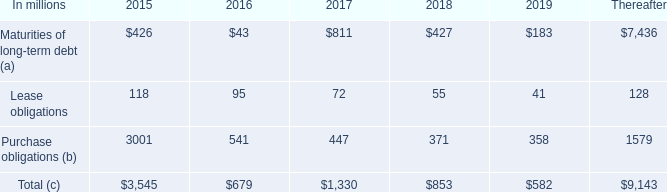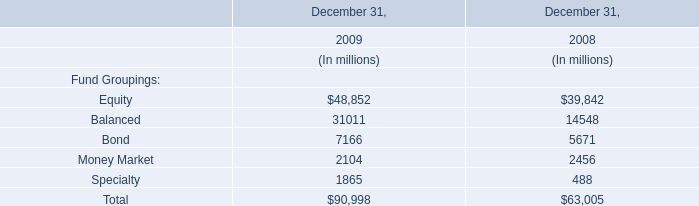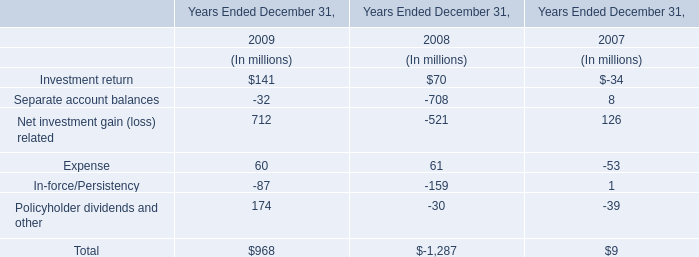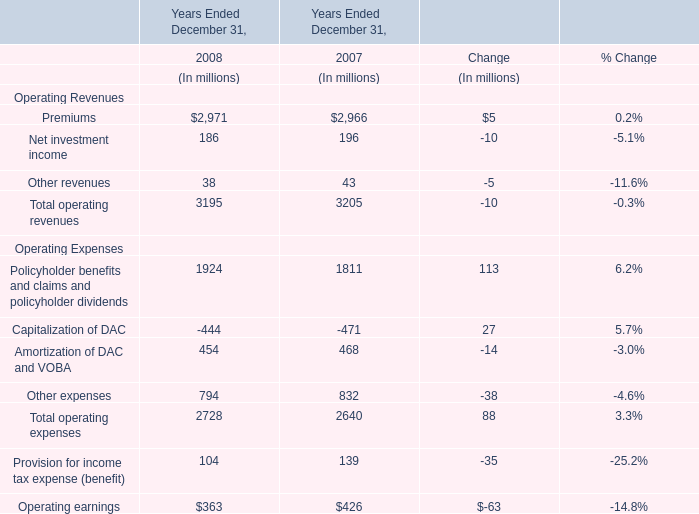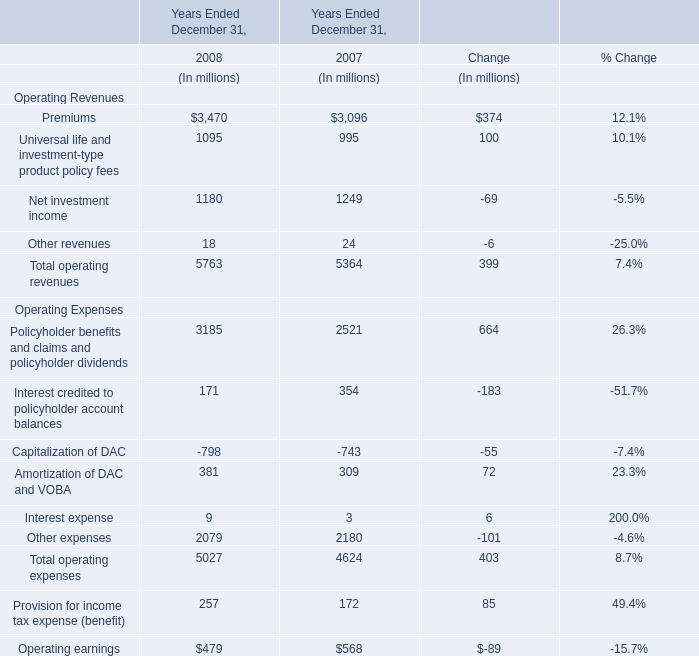What's the growth rate of Total operating revenues in 2008? 
Computations: ((5763 - 5364) / 5364)
Answer: 0.07438. 